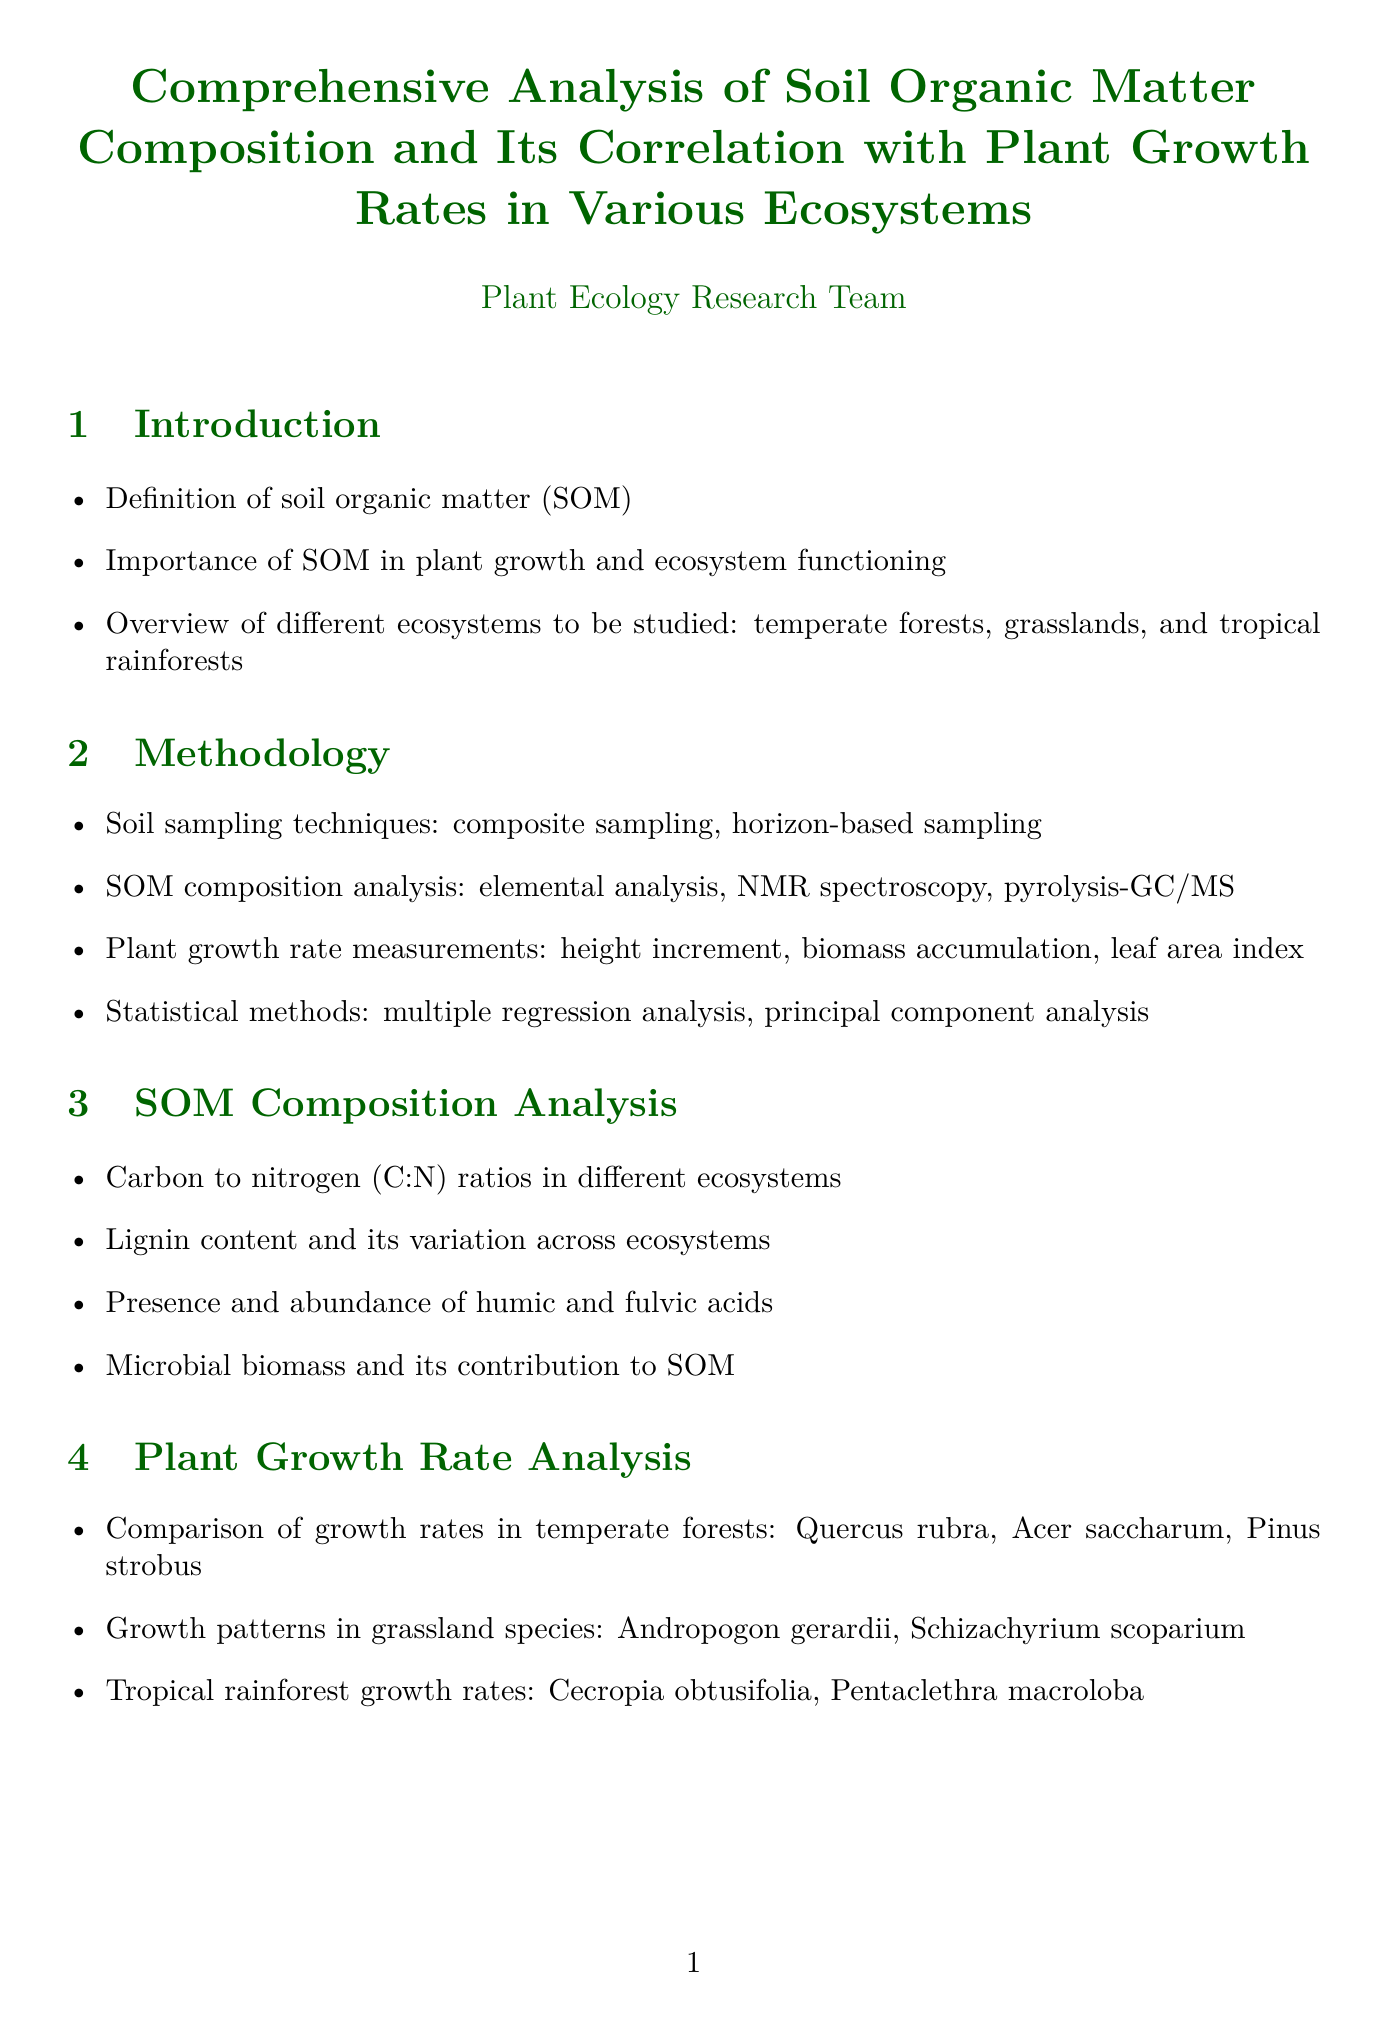What is the title of the report? The title is explicitly stated at the beginning of the document, summarizing the topic.
Answer: Comprehensive Analysis of Soil Organic Matter Composition and Its Correlation with Plant Growth Rates in Various Ecosystems What ecosystems are included in the study? The introduction lists the ecosystems to be studied for soil organic matter's effects on plant growth.
Answer: Temperate forests, grasslands, and tropical rainforests What methods were used to analyze SOM composition? The methodology section details various techniques for analyzing soil organic matter.
Answer: Elemental analysis, NMR spectroscopy, pyrolysis-GC/MS Which plant species were examined in temperate forests? The document specifies the plant species compared for growth rates in temperate forests.
Answer: Quercus rubra, Acer saccharum, Pinus strobus What is the relationship discussed between C:N ratio and plant growth rates? The correlation analysis section indicates a direct link between soil composition and plant growth.
Answer: Relationship between C:N ratio and plant growth rates Which type of organic matter content impacts nutrient availability? The content discusses the significance of a specific type of organic matter in relation to nutrient cycling.
Answer: Lignin content What does the report suggest for ecosystem management? The discussion focuses on strategies for managing ecosystems based on the findings of the study.
Answer: Implications for ecosystem management and restoration What are the recommendations for sustainable soil management practices? The conclusion emphasizes practices that should be followed for better soil health and plant growth.
Answer: Recommendations for sustainable soil management practices based on SOM composition 